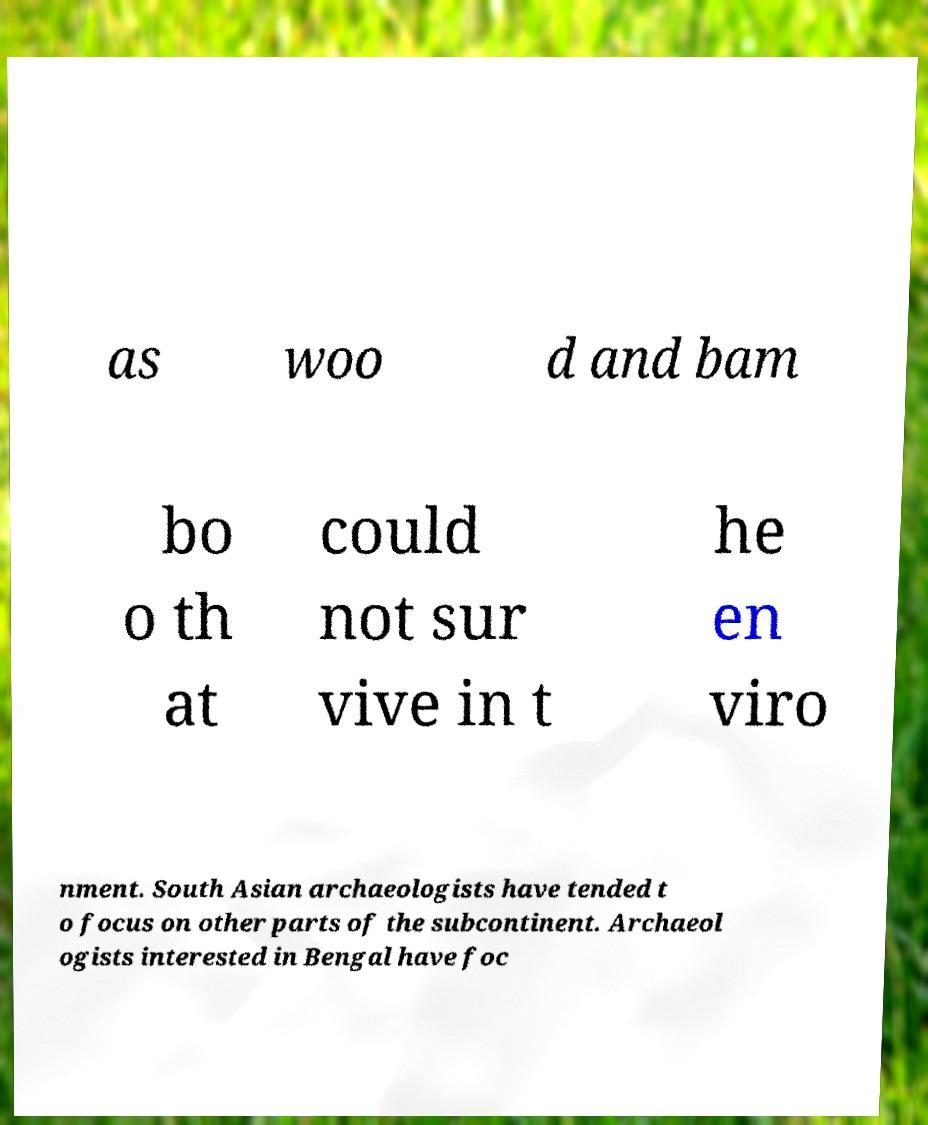Can you read and provide the text displayed in the image?This photo seems to have some interesting text. Can you extract and type it out for me? as woo d and bam bo o th at could not sur vive in t he en viro nment. South Asian archaeologists have tended t o focus on other parts of the subcontinent. Archaeol ogists interested in Bengal have foc 